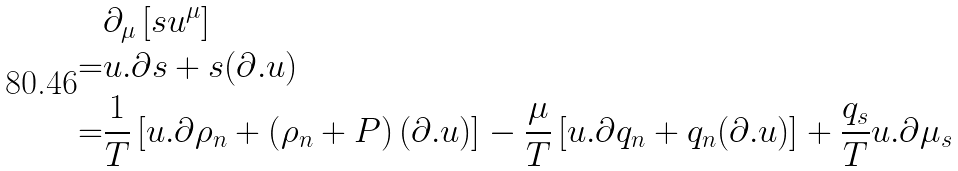<formula> <loc_0><loc_0><loc_500><loc_500>& \partial _ { \mu } \left [ s u ^ { \mu } \right ] \\ = & u . \partial s + s ( \partial . u ) \\ = & \frac { 1 } { T } \left [ u . \partial \rho _ { n } + \left ( \rho _ { n } + P \right ) ( \partial . u ) \right ] - \frac { \mu } { T } \left [ u . \partial q _ { n } + q _ { n } ( \partial . u ) \right ] + \frac { q _ { s } } { T } u . \partial \mu _ { s }</formula> 